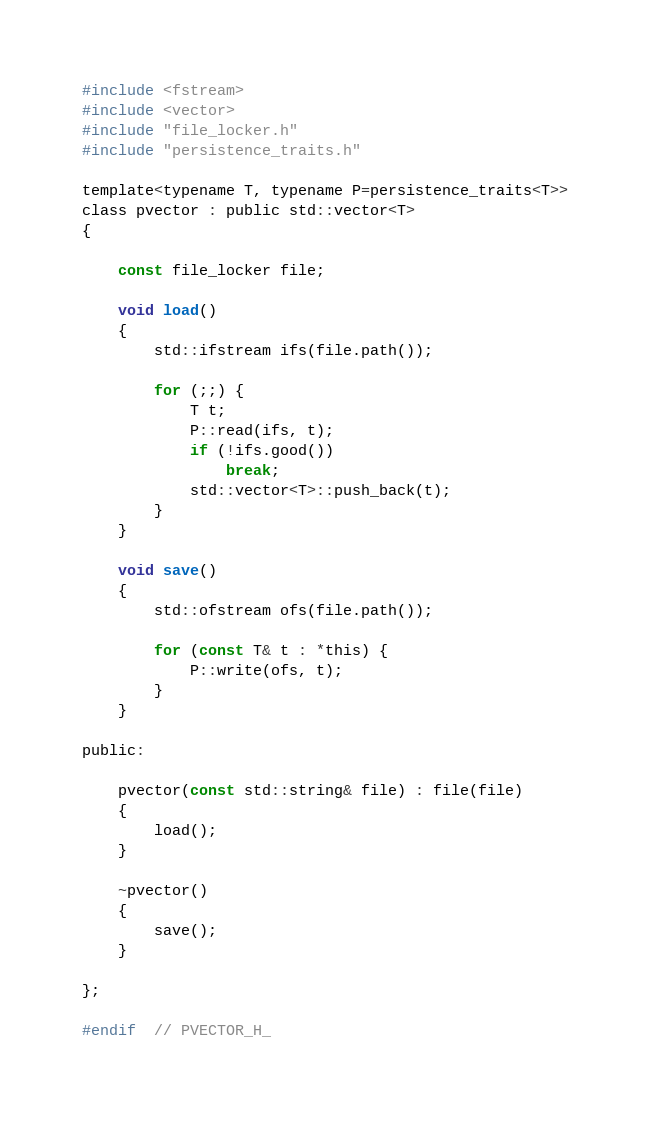Convert code to text. <code><loc_0><loc_0><loc_500><loc_500><_C_>
#include <fstream>
#include <vector>
#include "file_locker.h"
#include "persistence_traits.h"

template<typename T, typename P=persistence_traits<T>>
class pvector : public std::vector<T>
{

	const file_locker file;

	void load()
	{
		std::ifstream ifs(file.path());

		for (;;) {
			T t;
			P::read(ifs, t);
			if (!ifs.good())
				break;
			std::vector<T>::push_back(t);
		}
	}

	void save()
	{
		std::ofstream ofs(file.path());

		for (const T& t : *this) {
			P::write(ofs, t);
		}
	}

public:

	pvector(const std::string& file) : file(file)
	{
		load();
	}

	~pvector()
	{
		save();
	}

};

#endif  // PVECTOR_H_
</code> 